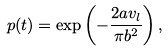Convert formula to latex. <formula><loc_0><loc_0><loc_500><loc_500>p ( t ) = \exp \left ( - \frac { 2 a v _ { l } } { \pi b ^ { 2 } } \right ) ,</formula> 